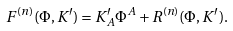<formula> <loc_0><loc_0><loc_500><loc_500>F ^ { ( n ) } ( \Phi , K ^ { \prime } ) = K _ { A } ^ { \prime } \Phi ^ { A } + R ^ { ( n ) } ( \Phi , K ^ { \prime } ) .</formula> 